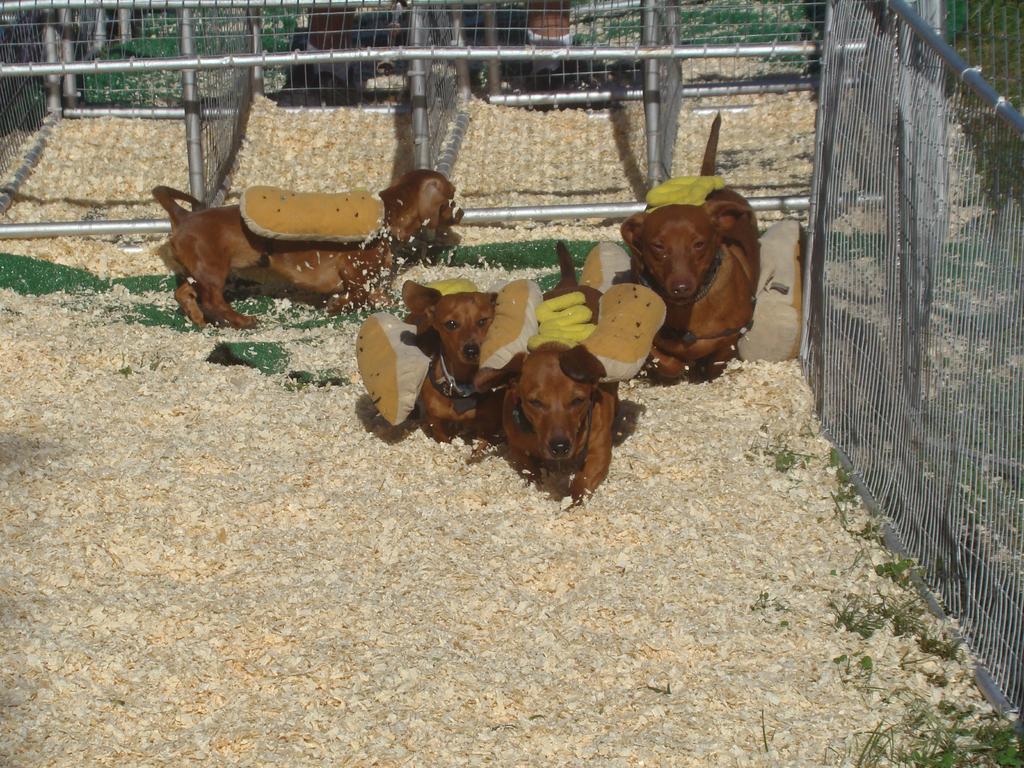Please provide a concise description of this image. In this picture I can observe four dogs which are in brown color. There is fencing in this picture. On the top right side I can observe some plants on the ground. 